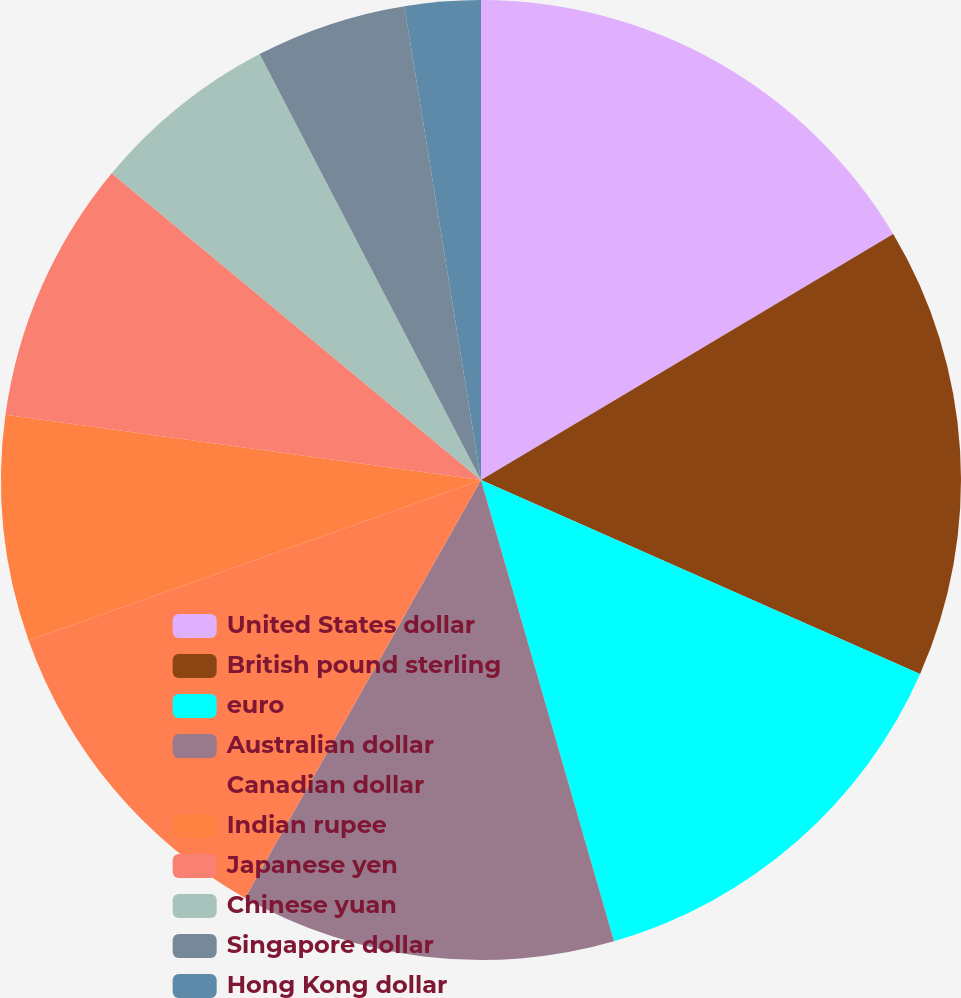Convert chart to OTSL. <chart><loc_0><loc_0><loc_500><loc_500><pie_chart><fcel>United States dollar<fcel>British pound sterling<fcel>euro<fcel>Australian dollar<fcel>Canadian dollar<fcel>Indian rupee<fcel>Japanese yen<fcel>Chinese yuan<fcel>Singapore dollar<fcel>Hong Kong dollar<nl><fcel>16.44%<fcel>15.18%<fcel>13.91%<fcel>12.65%<fcel>11.39%<fcel>7.6%<fcel>8.86%<fcel>6.34%<fcel>5.08%<fcel>2.55%<nl></chart> 